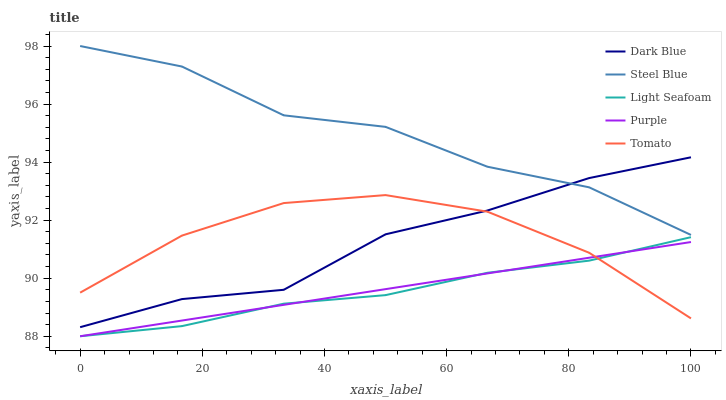Does Light Seafoam have the minimum area under the curve?
Answer yes or no. Yes. Does Steel Blue have the maximum area under the curve?
Answer yes or no. Yes. Does Dark Blue have the minimum area under the curve?
Answer yes or no. No. Does Dark Blue have the maximum area under the curve?
Answer yes or no. No. Is Purple the smoothest?
Answer yes or no. Yes. Is Steel Blue the roughest?
Answer yes or no. Yes. Is Dark Blue the smoothest?
Answer yes or no. No. Is Dark Blue the roughest?
Answer yes or no. No. Does Purple have the lowest value?
Answer yes or no. Yes. Does Dark Blue have the lowest value?
Answer yes or no. No. Does Steel Blue have the highest value?
Answer yes or no. Yes. Does Dark Blue have the highest value?
Answer yes or no. No. Is Purple less than Steel Blue?
Answer yes or no. Yes. Is Steel Blue greater than Tomato?
Answer yes or no. Yes. Does Purple intersect Tomato?
Answer yes or no. Yes. Is Purple less than Tomato?
Answer yes or no. No. Is Purple greater than Tomato?
Answer yes or no. No. Does Purple intersect Steel Blue?
Answer yes or no. No. 